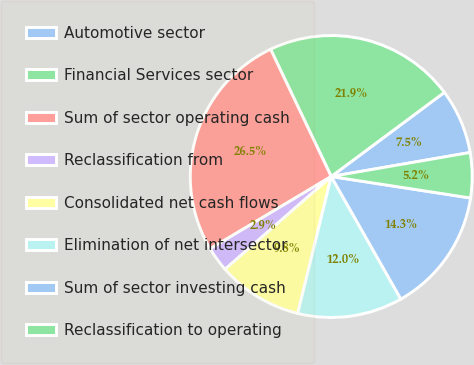Convert chart. <chart><loc_0><loc_0><loc_500><loc_500><pie_chart><fcel>Automotive sector<fcel>Financial Services sector<fcel>Sum of sector operating cash<fcel>Reclassification from<fcel>Consolidated net cash flows<fcel>Elimination of net intersector<fcel>Sum of sector investing cash<fcel>Reclassification to operating<nl><fcel>7.45%<fcel>21.9%<fcel>26.49%<fcel>2.86%<fcel>9.75%<fcel>12.04%<fcel>14.34%<fcel>5.16%<nl></chart> 